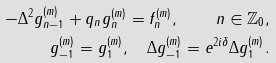Convert formula to latex. <formula><loc_0><loc_0><loc_500><loc_500>- \Delta ^ { 2 } g _ { n - 1 } ^ { ( m ) } + q _ { n } g _ { n } ^ { ( m ) } = f _ { n } ^ { ( m ) } , \quad n \in \mathbb { Z } _ { 0 } , \\ g _ { - 1 } ^ { ( m ) } = g _ { 1 } ^ { ( m ) } , \quad \Delta g _ { - 1 } ^ { ( m ) } = e ^ { 2 i \delta } \Delta g _ { 1 } ^ { ( m ) } .</formula> 